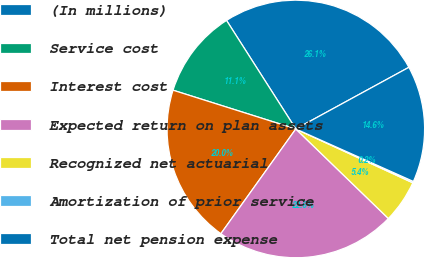Convert chart. <chart><loc_0><loc_0><loc_500><loc_500><pie_chart><fcel>(In millions)<fcel>Service cost<fcel>Interest cost<fcel>Expected return on plan assets<fcel>Recognized net actuarial<fcel>Amortization of prior service<fcel>Total net pension expense<nl><fcel>26.1%<fcel>11.09%<fcel>19.98%<fcel>22.65%<fcel>5.37%<fcel>0.18%<fcel>14.63%<nl></chart> 